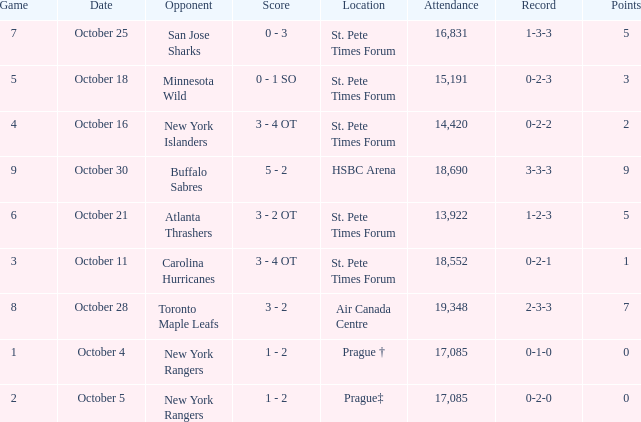What was the attendance when their record stood at 0-2-2? 14420.0. 